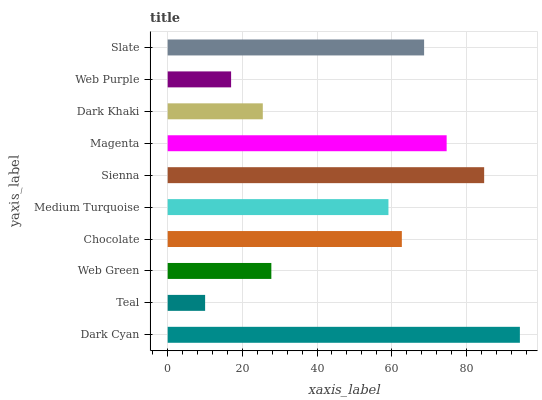Is Teal the minimum?
Answer yes or no. Yes. Is Dark Cyan the maximum?
Answer yes or no. Yes. Is Web Green the minimum?
Answer yes or no. No. Is Web Green the maximum?
Answer yes or no. No. Is Web Green greater than Teal?
Answer yes or no. Yes. Is Teal less than Web Green?
Answer yes or no. Yes. Is Teal greater than Web Green?
Answer yes or no. No. Is Web Green less than Teal?
Answer yes or no. No. Is Chocolate the high median?
Answer yes or no. Yes. Is Medium Turquoise the low median?
Answer yes or no. Yes. Is Slate the high median?
Answer yes or no. No. Is Dark Khaki the low median?
Answer yes or no. No. 